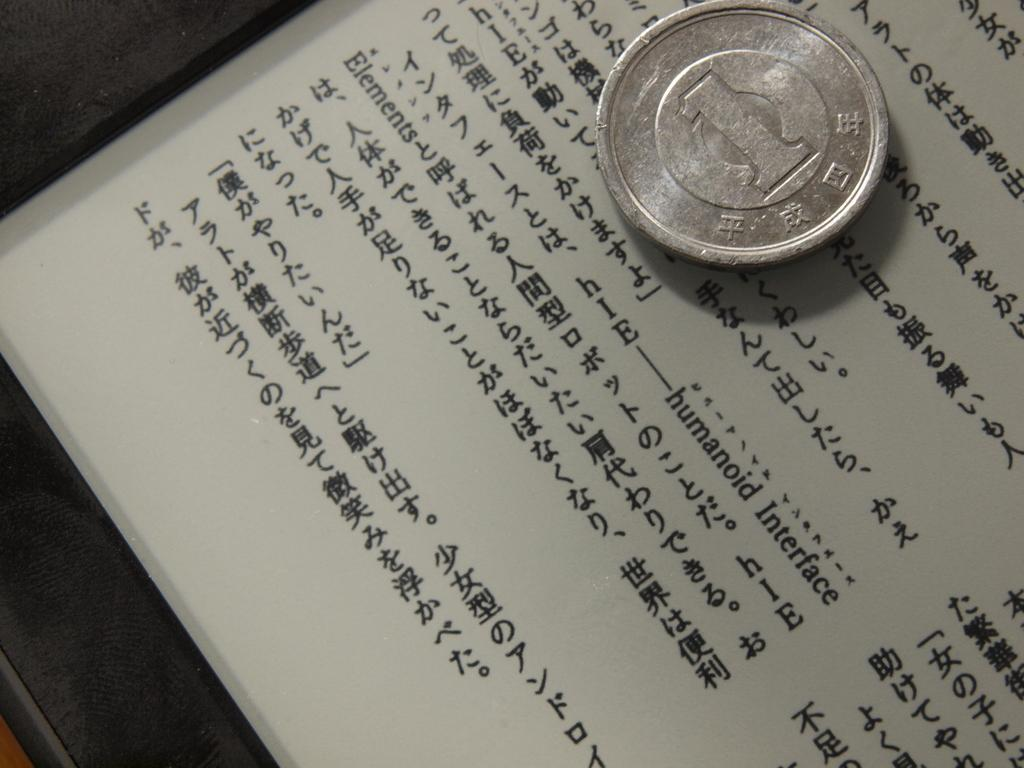<image>
Create a compact narrative representing the image presented. A one Yen silver coin sits on a page of chinese writing that also has sporadic english text within it. 